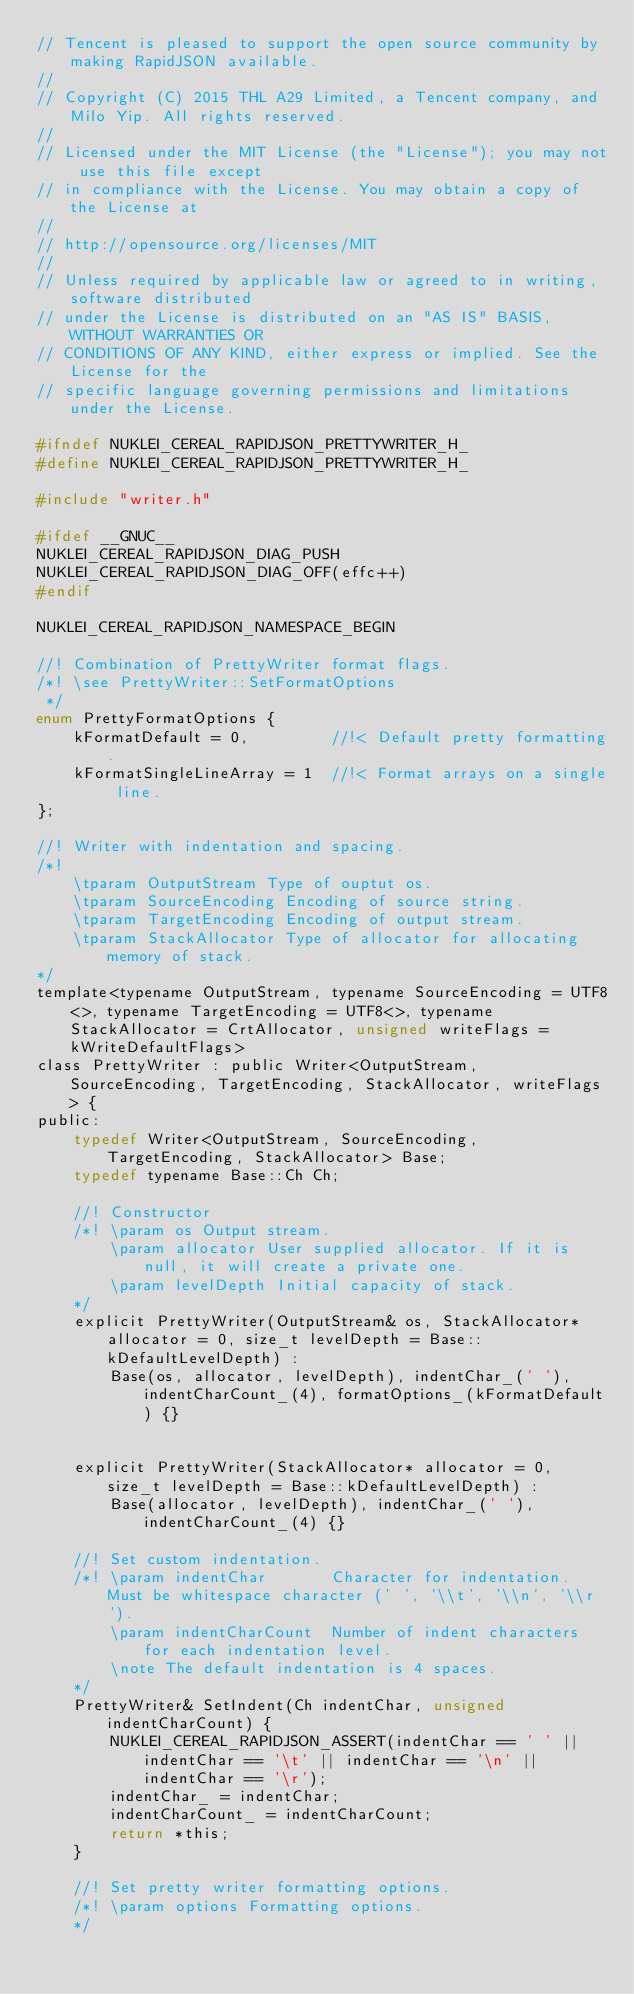Convert code to text. <code><loc_0><loc_0><loc_500><loc_500><_C_>// Tencent is pleased to support the open source community by making RapidJSON available.
// 
// Copyright (C) 2015 THL A29 Limited, a Tencent company, and Milo Yip. All rights reserved.
//
// Licensed under the MIT License (the "License"); you may not use this file except
// in compliance with the License. You may obtain a copy of the License at
//
// http://opensource.org/licenses/MIT
//
// Unless required by applicable law or agreed to in writing, software distributed 
// under the License is distributed on an "AS IS" BASIS, WITHOUT WARRANTIES OR 
// CONDITIONS OF ANY KIND, either express or implied. See the License for the 
// specific language governing permissions and limitations under the License.

#ifndef NUKLEI_CEREAL_RAPIDJSON_PRETTYWRITER_H_
#define NUKLEI_CEREAL_RAPIDJSON_PRETTYWRITER_H_

#include "writer.h"

#ifdef __GNUC__
NUKLEI_CEREAL_RAPIDJSON_DIAG_PUSH
NUKLEI_CEREAL_RAPIDJSON_DIAG_OFF(effc++)
#endif

NUKLEI_CEREAL_RAPIDJSON_NAMESPACE_BEGIN

//! Combination of PrettyWriter format flags.
/*! \see PrettyWriter::SetFormatOptions
 */
enum PrettyFormatOptions {
    kFormatDefault = 0,         //!< Default pretty formatting.
    kFormatSingleLineArray = 1  //!< Format arrays on a single line.
};

//! Writer with indentation and spacing.
/*!
    \tparam OutputStream Type of ouptut os.
    \tparam SourceEncoding Encoding of source string.
    \tparam TargetEncoding Encoding of output stream.
    \tparam StackAllocator Type of allocator for allocating memory of stack.
*/
template<typename OutputStream, typename SourceEncoding = UTF8<>, typename TargetEncoding = UTF8<>, typename StackAllocator = CrtAllocator, unsigned writeFlags = kWriteDefaultFlags>
class PrettyWriter : public Writer<OutputStream, SourceEncoding, TargetEncoding, StackAllocator, writeFlags> {
public:
    typedef Writer<OutputStream, SourceEncoding, TargetEncoding, StackAllocator> Base;
    typedef typename Base::Ch Ch;

    //! Constructor
    /*! \param os Output stream.
        \param allocator User supplied allocator. If it is null, it will create a private one.
        \param levelDepth Initial capacity of stack.
    */
    explicit PrettyWriter(OutputStream& os, StackAllocator* allocator = 0, size_t levelDepth = Base::kDefaultLevelDepth) : 
        Base(os, allocator, levelDepth), indentChar_(' '), indentCharCount_(4), formatOptions_(kFormatDefault) {}


    explicit PrettyWriter(StackAllocator* allocator = 0, size_t levelDepth = Base::kDefaultLevelDepth) : 
        Base(allocator, levelDepth), indentChar_(' '), indentCharCount_(4) {}

    //! Set custom indentation.
    /*! \param indentChar       Character for indentation. Must be whitespace character (' ', '\\t', '\\n', '\\r').
        \param indentCharCount  Number of indent characters for each indentation level.
        \note The default indentation is 4 spaces.
    */
    PrettyWriter& SetIndent(Ch indentChar, unsigned indentCharCount) {
        NUKLEI_CEREAL_RAPIDJSON_ASSERT(indentChar == ' ' || indentChar == '\t' || indentChar == '\n' || indentChar == '\r');
        indentChar_ = indentChar;
        indentCharCount_ = indentCharCount;
        return *this;
    }

    //! Set pretty writer formatting options.
    /*! \param options Formatting options.
    */</code> 